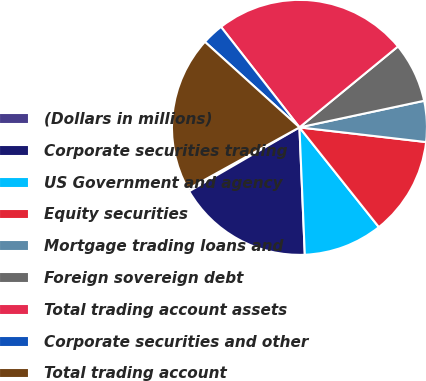<chart> <loc_0><loc_0><loc_500><loc_500><pie_chart><fcel>(Dollars in millions)<fcel>Corporate securities trading<fcel>US Government and agency<fcel>Equity securities<fcel>Mortgage trading loans and<fcel>Foreign sovereign debt<fcel>Total trading account assets<fcel>Corporate securities and other<fcel>Total trading account<nl><fcel>0.32%<fcel>17.31%<fcel>10.03%<fcel>12.46%<fcel>5.18%<fcel>7.6%<fcel>24.6%<fcel>2.75%<fcel>19.74%<nl></chart> 